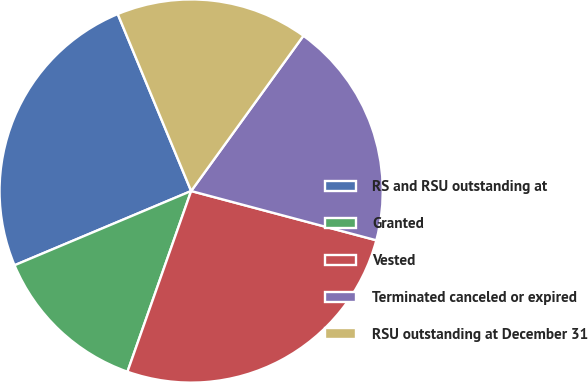<chart> <loc_0><loc_0><loc_500><loc_500><pie_chart><fcel>RS and RSU outstanding at<fcel>Granted<fcel>Vested<fcel>Terminated canceled or expired<fcel>RSU outstanding at December 31<nl><fcel>25.07%<fcel>13.27%<fcel>26.25%<fcel>19.17%<fcel>16.22%<nl></chart> 